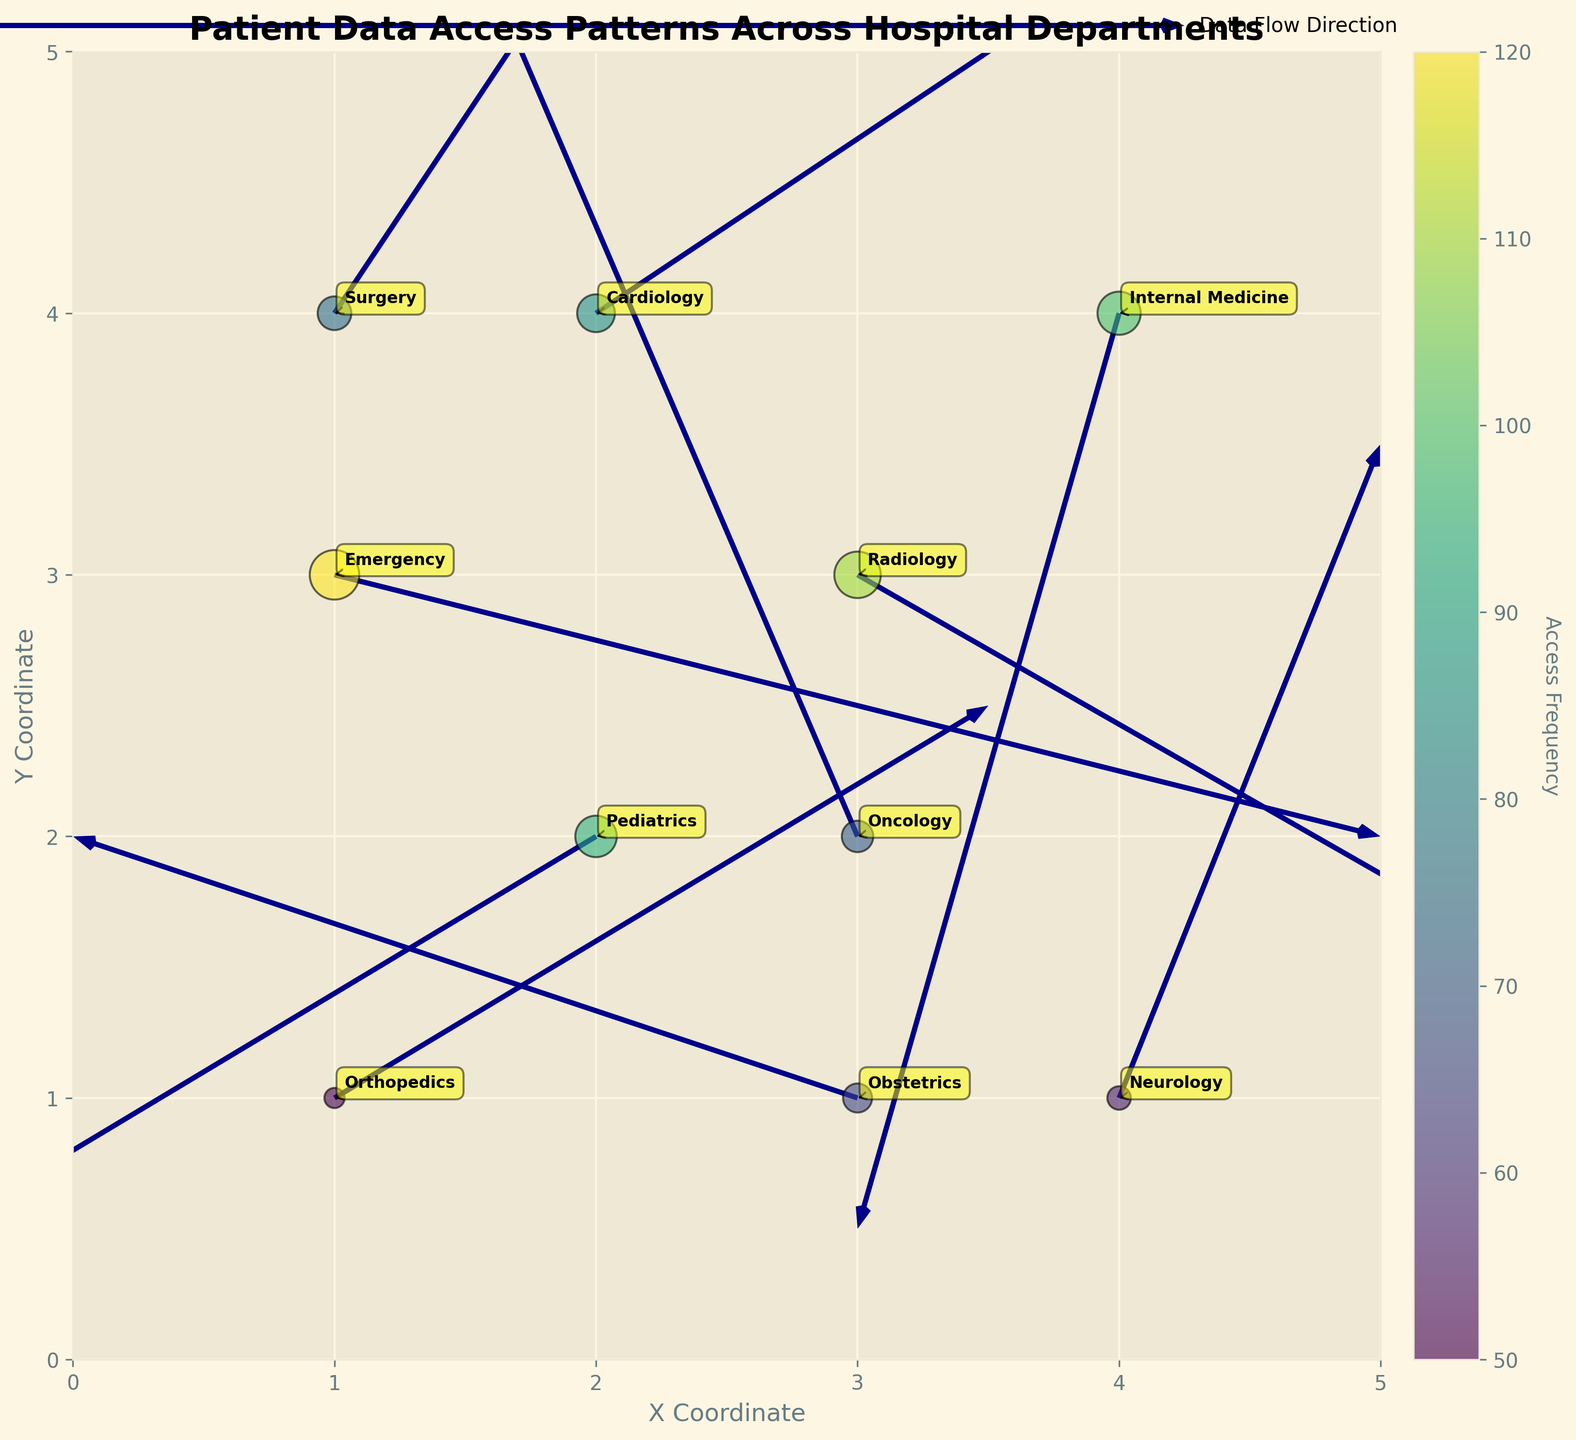What is the title of the figure? The title of the figure is usually placed at the top of the graph and is meant to succinctly describe what the figure is about.
Answer: Patient Data Access Patterns Across Hospital Departments How many departments are represented in the figure? To find the number of departments, one would count the unique data points or labels present in the plot.
Answer: 10 Which department has the highest frequency of data access requests? The department with the highest frequency can be identified by the largest marker on the scatter plot, which in this case is "Emergency" with a frequency of 120.
Answer: Emergency In which direction does data flow most strongly for the Radiology department? The direction of data flow can be determined by examining the direction of the arrow or vector originating from the Radiology department.
Answer: Approximately down-left Which department has the lowest frequency of data access requests? To find this, identify the department with the smallest marker size, indicating the lowest frequency, which is "Orthopedics" with a frequency of 50.
Answer: Orthopedics Are there any departments where data access requests are directed primarily upwards? Identify departments by looking at the vector directions; for "Oncology", the vector points primarily upwards (DirectionY = 0.7).
Answer: Oncology Between Cardiology and Oncology, which department has more frequent data access requests? Compare the marker sizes, where Cardiology has a frequency of 85 and Oncology has a frequency of 70. Therefore, Cardiology has more frequent requests.
Answer: Cardiology What is the average frequency of data access requests among all departments? Add up all the frequencies (120 + 85 + 70 + 55 + 95 + 110 + 75 + 100 + 50 + 65 = 825) and then divide by the number of departments (10).
Answer: 82.5 Which department has data flowing in a direction with a positive X component and a negative Y component? Look at directional components (DirectionX and DirectionY); the department with a positive X and negative Y is "Radiology" (DirectionX = 0.7, DirectionY = -0.4).
Answer: Radiology How does the data flow direction for Internal Medicine compare to that for Surgery? Compare their vectors; Internal Medicine flows down-left (negative X and negative Y direction), while Surgery flows up-right (positive X and positive Y direction).
Answer: Internal Medicine: down-left; Surgery: up-right 